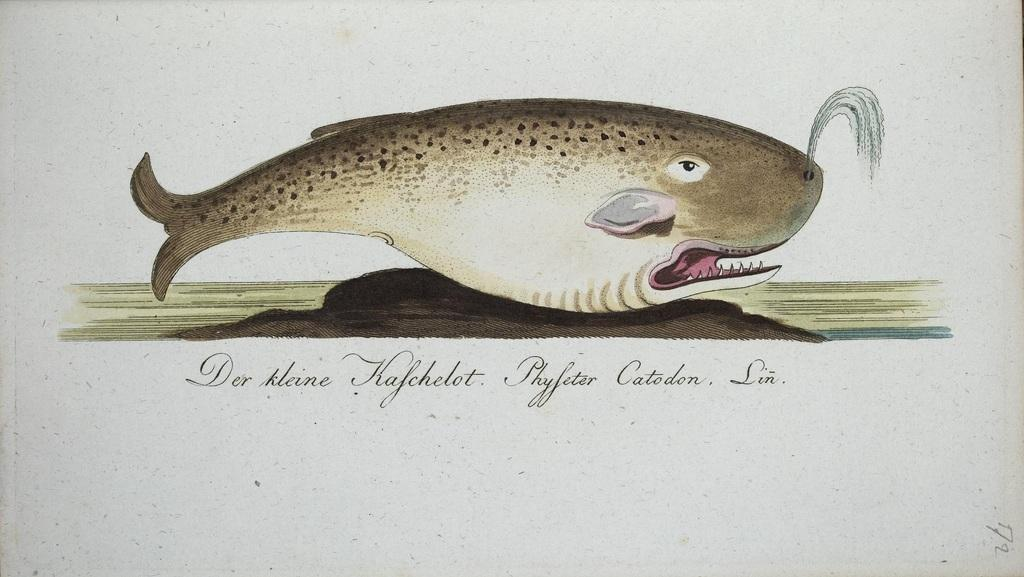What is shown on the paper in the image? There is a picture of a shark on the paper. What is the setting or environment depicted in the image? There is water depicted in the image. Is there any text present in the image? Yes, there is text at the bottom of the paper. How many tents are visible in the image? There are no tents present in the image; it features a picture of a shark in water with text at the bottom. What is the amount of water shown in the image? The image depicts water as the environment in which the shark is swimming, but it is not possible to determine an exact amount of water from the image. 